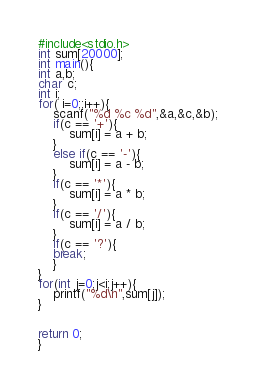<code> <loc_0><loc_0><loc_500><loc_500><_C_>#include<stdio.h>
int sum[20000];
int main(){
int a,b;
char c;
int i;
for( i=0;;i++){
    scanf("%d %c %d",&a,&c,&b);
    if(c == '+'){
        sum[i] = a + b;
    }
    else if(c == '-'){
        sum[i] = a - b;
    }
    if(c == '*'){
        sum[i] = a * b;
    }
    if(c == '/'){
        sum[i] = a / b;
    }
    if(c == '?'){
    break;
    }
}
for(int j=0;j<i;j++){
    printf("%d\n",sum[j]);
}


return 0;
}

</code> 